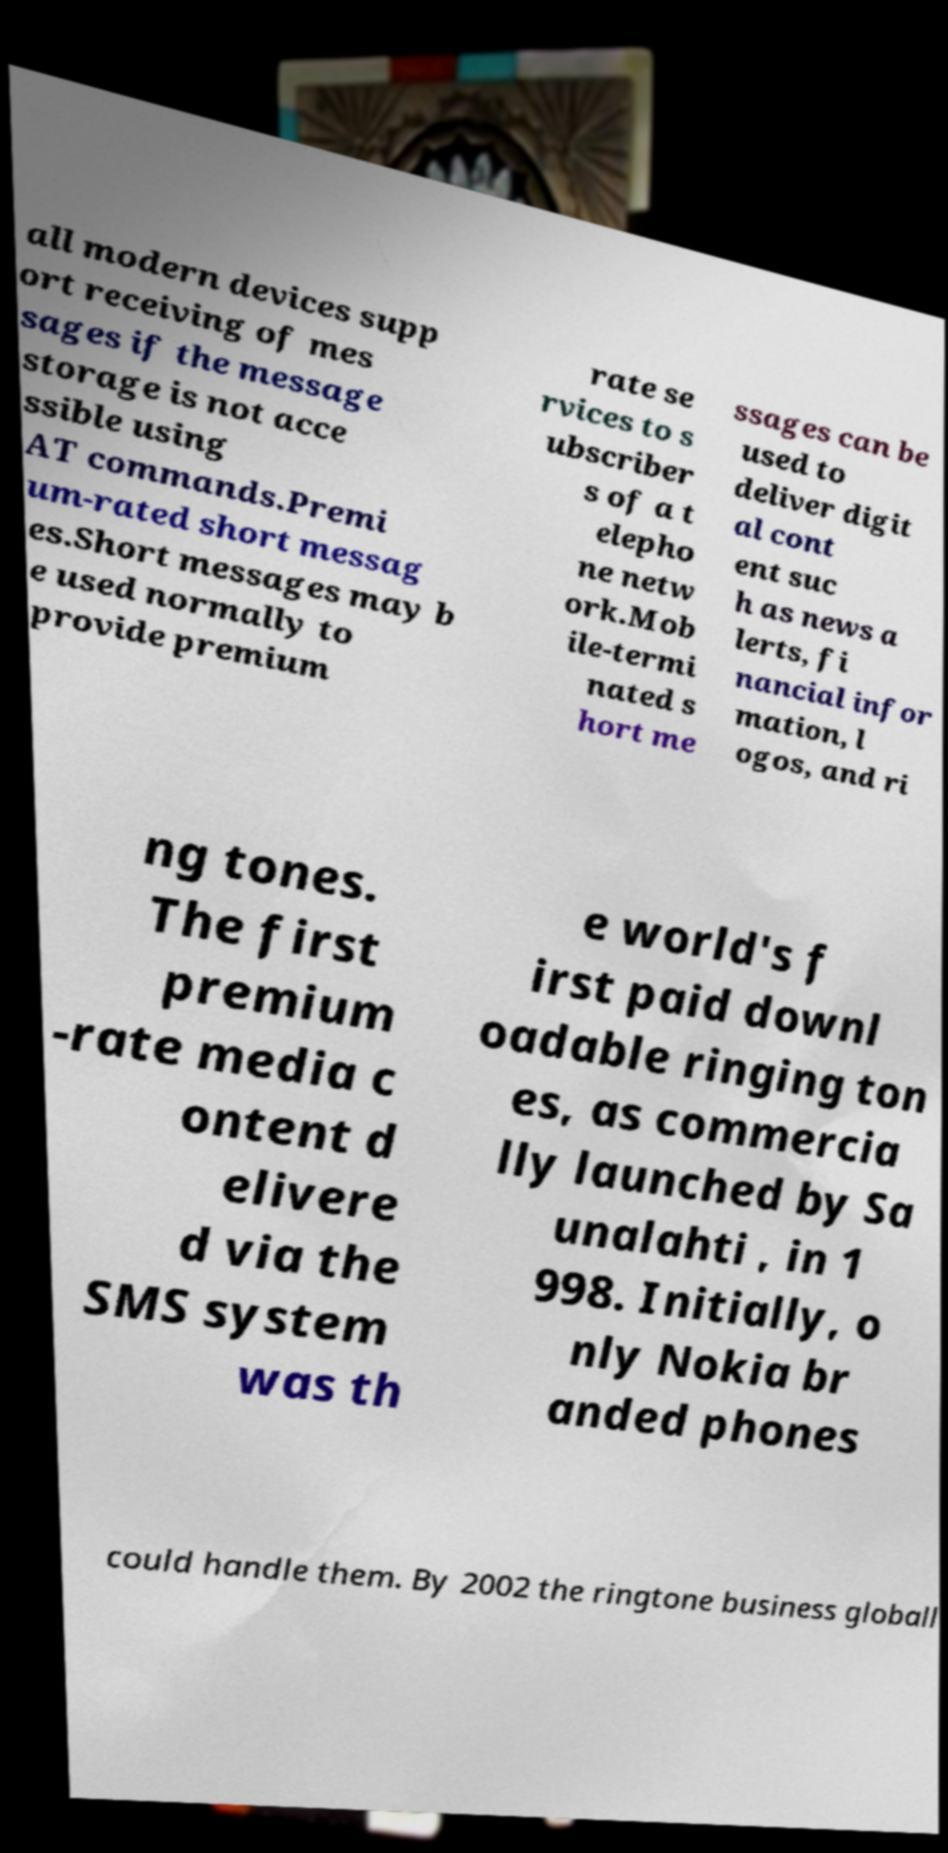Can you accurately transcribe the text from the provided image for me? all modern devices supp ort receiving of mes sages if the message storage is not acce ssible using AT commands.Premi um-rated short messag es.Short messages may b e used normally to provide premium rate se rvices to s ubscriber s of a t elepho ne netw ork.Mob ile-termi nated s hort me ssages can be used to deliver digit al cont ent suc h as news a lerts, fi nancial infor mation, l ogos, and ri ng tones. The first premium -rate media c ontent d elivere d via the SMS system was th e world's f irst paid downl oadable ringing ton es, as commercia lly launched by Sa unalahti , in 1 998. Initially, o nly Nokia br anded phones could handle them. By 2002 the ringtone business globall 